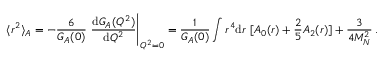Convert formula to latex. <formula><loc_0><loc_0><loc_500><loc_500>\langle r ^ { 2 } \rangle _ { A } = - \frac { 6 } { G _ { A } ( 0 ) } \ \frac { d G _ { A } ( Q ^ { 2 } ) } { d Q ^ { 2 } } \Big | _ { Q ^ { 2 } = 0 } = \frac { 1 } { G _ { A } ( 0 ) } \int r ^ { 4 } d r \ [ A _ { 0 } ( r ) + \frac { 2 } { 5 } A _ { 2 } ( r ) ] + \frac { 3 } { 4 M _ { N } ^ { 2 } } \, .</formula> 